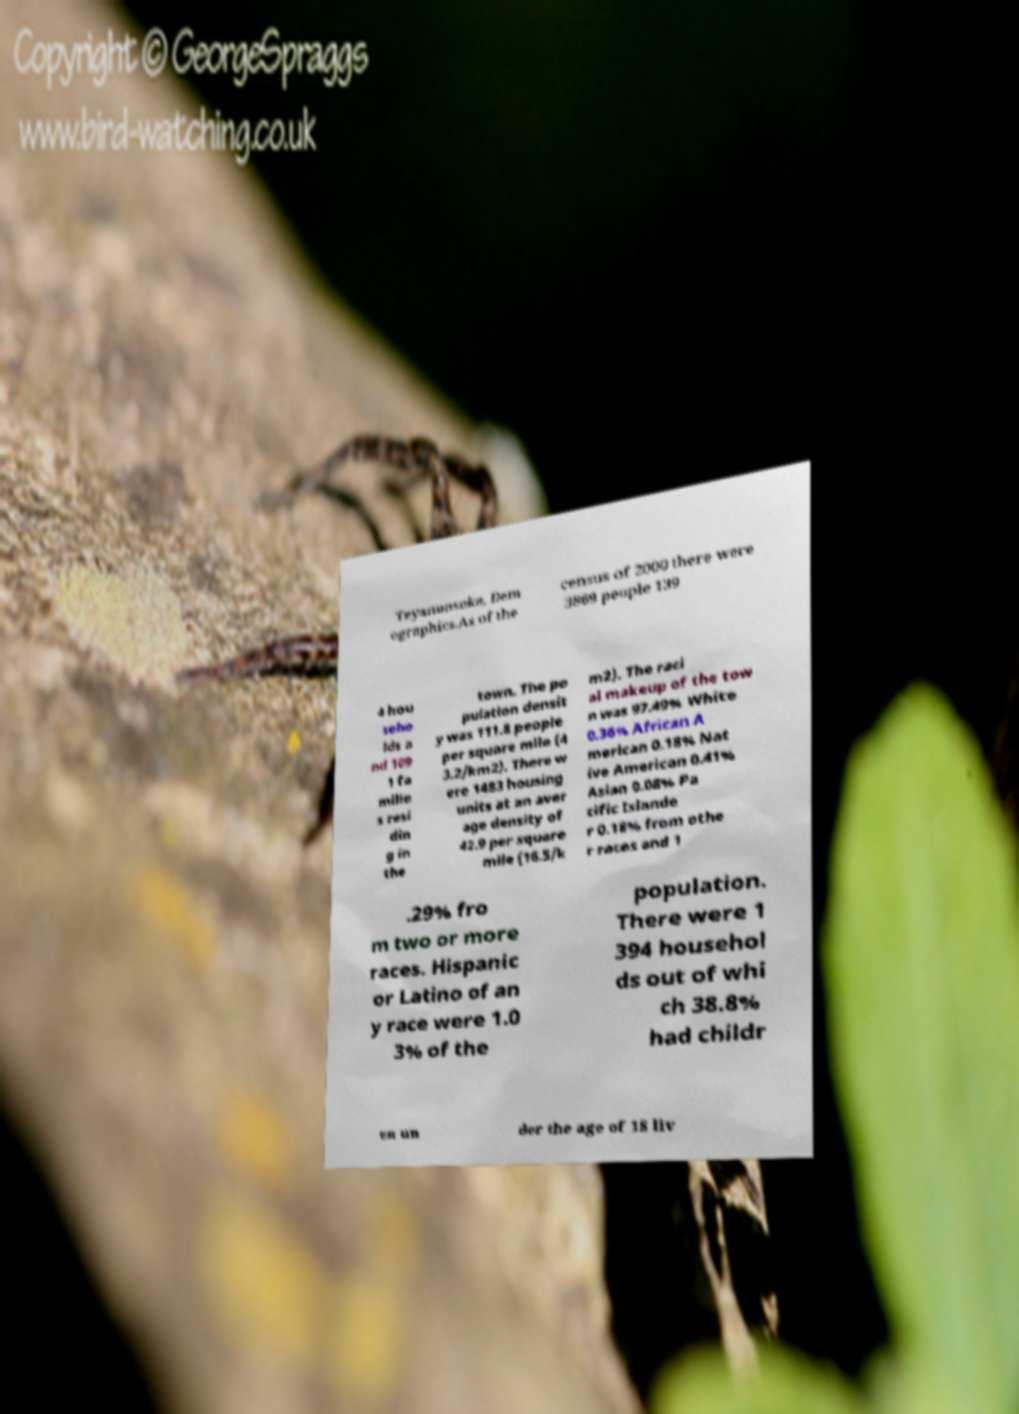Could you assist in decoding the text presented in this image and type it out clearly? Teyanunsoke, Dem ographics.As of the census of 2000 there were 3869 people 139 4 hou seho lds a nd 109 1 fa milie s resi din g in the town. The po pulation densit y was 111.8 people per square mile (4 3.2/km2). There w ere 1483 housing units at an aver age density of 42.9 per square mile (16.5/k m2). The raci al makeup of the tow n was 97.49% White 0.36% African A merican 0.18% Nat ive American 0.41% Asian 0.08% Pa cific Islande r 0.18% from othe r races and 1 .29% fro m two or more races. Hispanic or Latino of an y race were 1.0 3% of the population. There were 1 394 househol ds out of whi ch 38.8% had childr en un der the age of 18 liv 